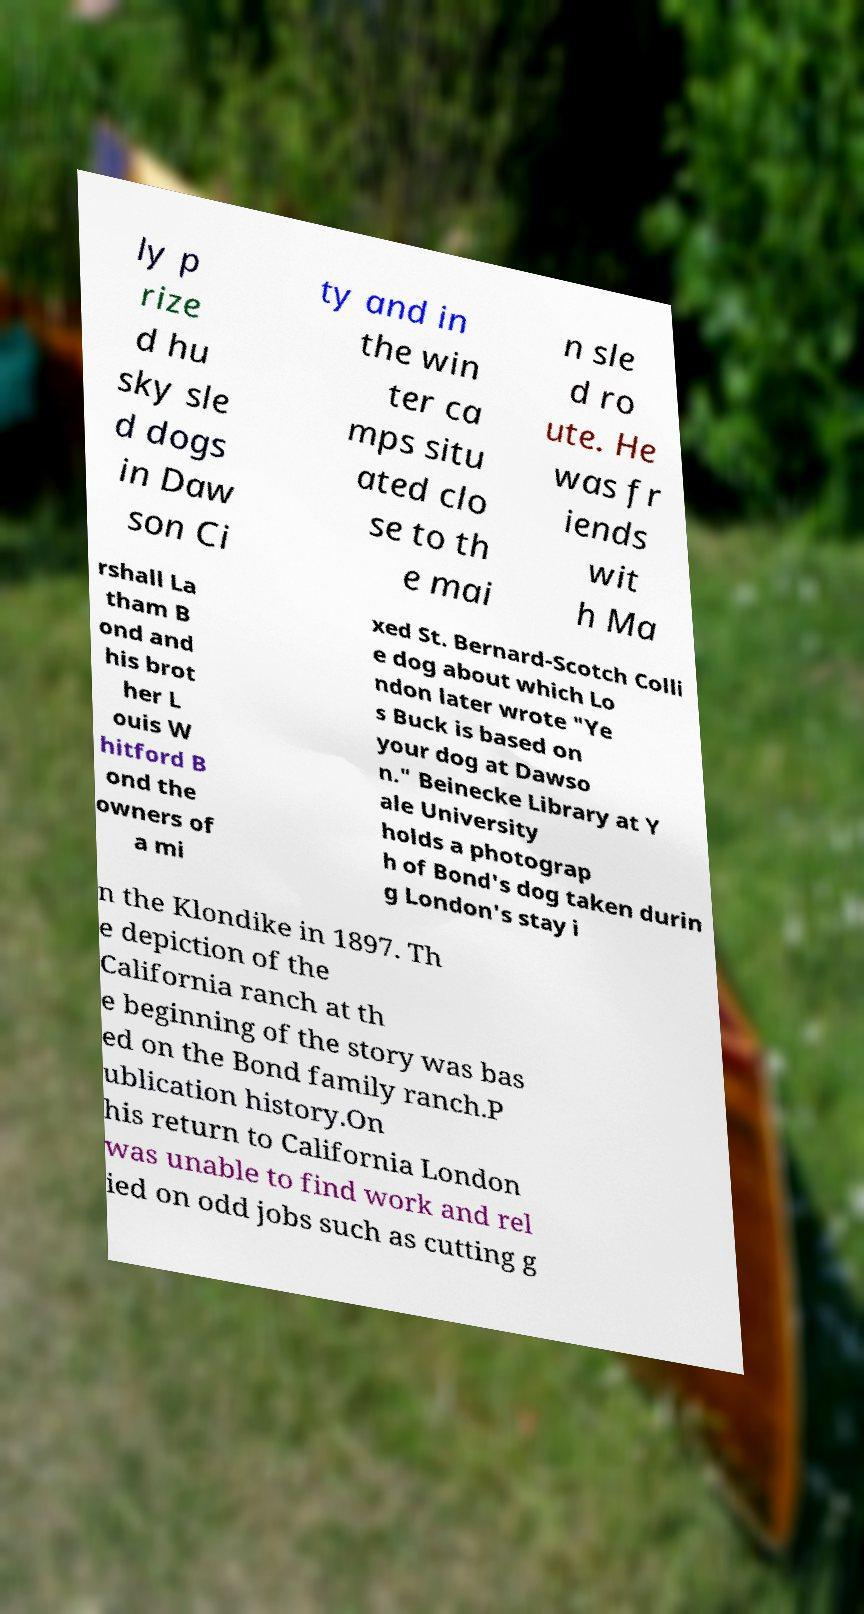Could you assist in decoding the text presented in this image and type it out clearly? ly p rize d hu sky sle d dogs in Daw son Ci ty and in the win ter ca mps situ ated clo se to th e mai n sle d ro ute. He was fr iends wit h Ma rshall La tham B ond and his brot her L ouis W hitford B ond the owners of a mi xed St. Bernard-Scotch Colli e dog about which Lo ndon later wrote "Ye s Buck is based on your dog at Dawso n." Beinecke Library at Y ale University holds a photograp h of Bond's dog taken durin g London's stay i n the Klondike in 1897. Th e depiction of the California ranch at th e beginning of the story was bas ed on the Bond family ranch.P ublication history.On his return to California London was unable to find work and rel ied on odd jobs such as cutting g 